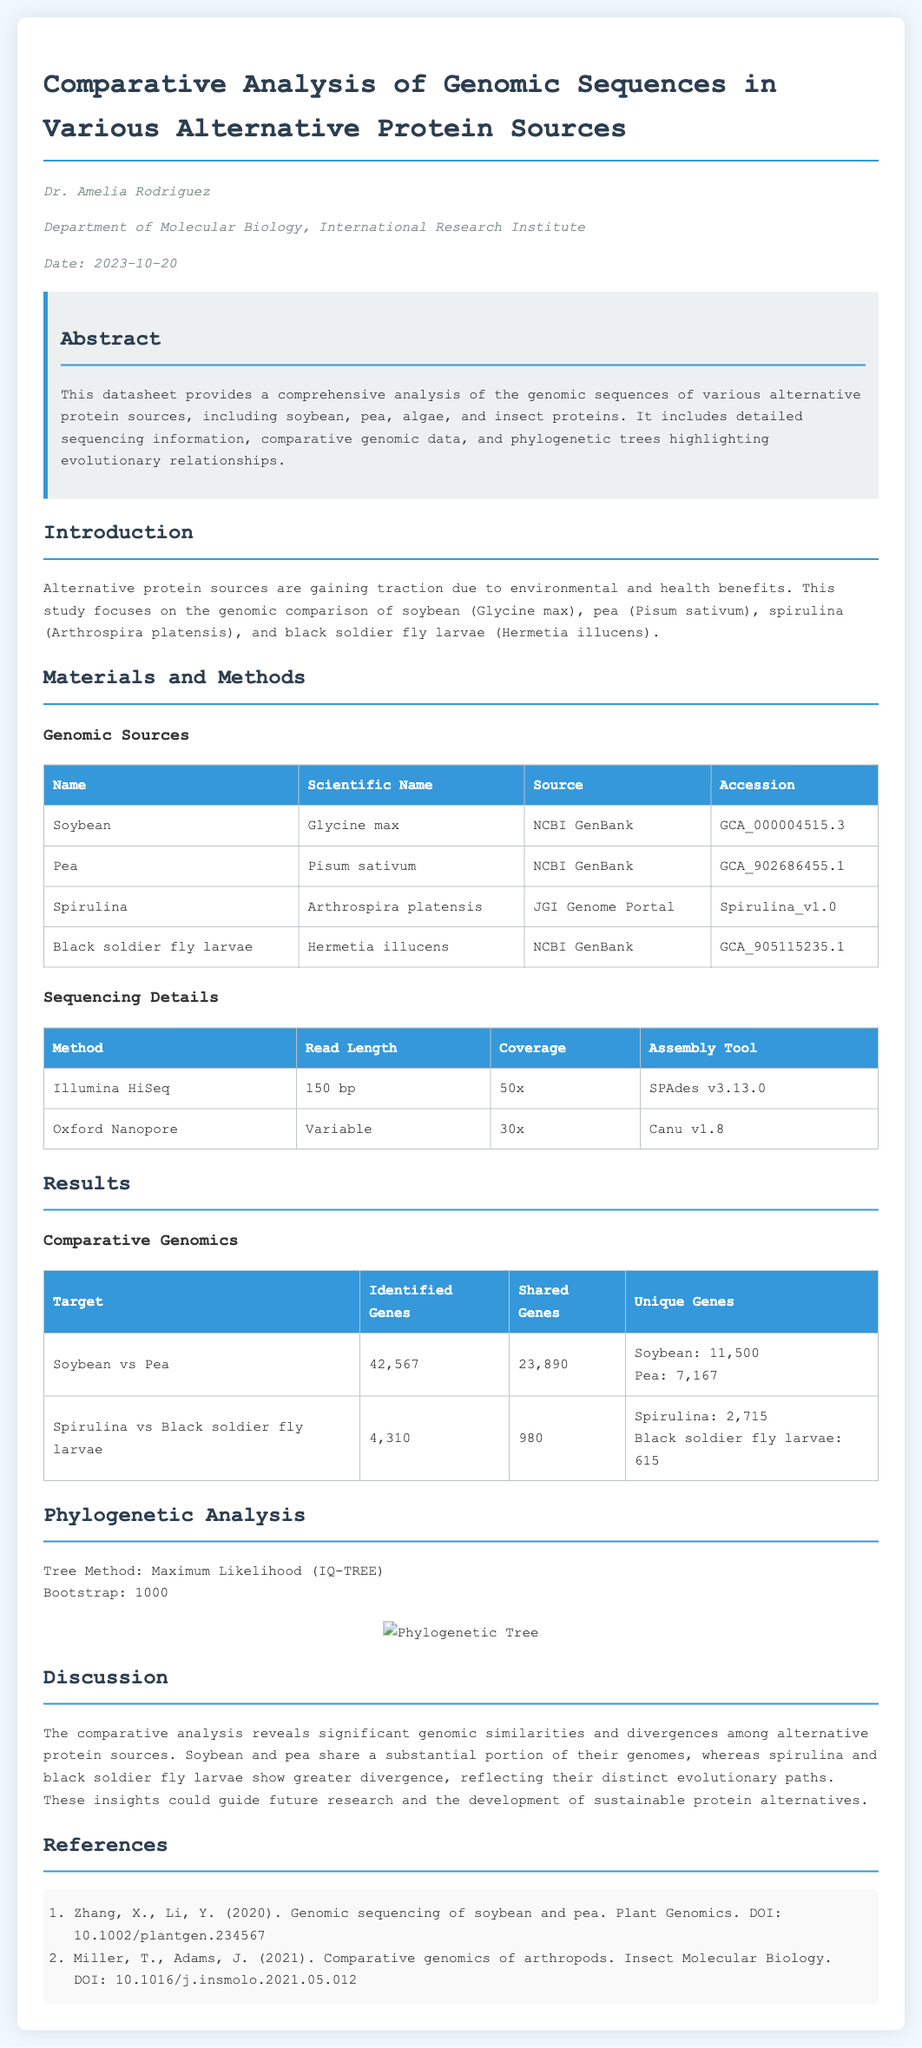What is the title of the datasheet? The title is stated at the beginning of the document, focusing on comparative analysis in alternative protein sources.
Answer: Comparative Analysis of Genomic Sequences in Various Alternative Protein Sources Who authored the datasheet? The document provides the name of the author in the author info section.
Answer: Dr. Amelia Rodriguez What is the accession number for soybean? The accession number is listed in the genomic sources table for soybean.
Answer: GCA_000004515.3 Which sequencing method had the highest coverage? The coverage details in the sequencing information indicate which method provided more extensive coverage.
Answer: Illumina HiSeq How many identified genes were found in the comparison of soybean and pea? The results table specifies the number of identified genes in the genomic comparison between soybean and pea.
Answer: 42,567 What is the tree method used for phylogenetic analysis? The document explicitly mentions the method used for constructing the phylogenetic tree in the analysis section.
Answer: Maximum Likelihood (IQ-TREE) Which alternative protein source has the most unique genes in its genomic analysis? The unique genes information in the comparative genomics table helps identify the source with the highest unique gene count.
Answer: Spirulina What is the bootstrap value mentioned in the document? The bootstrap value is mentioned in the phylogenetic analysis section and indicates the reliability of the phylogenetic tree.
Answer: 1000 Which database was used to source the genomic data for black soldier fly larvae? The metadata in the genomic sources table specifies the database from which the genomic data for black soldier fly larvae was obtained.
Answer: NCBI GenBank 